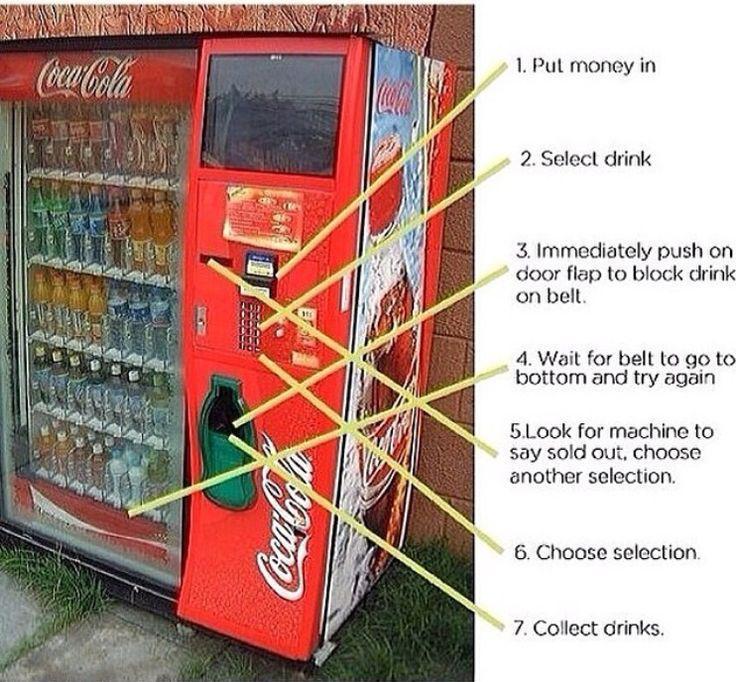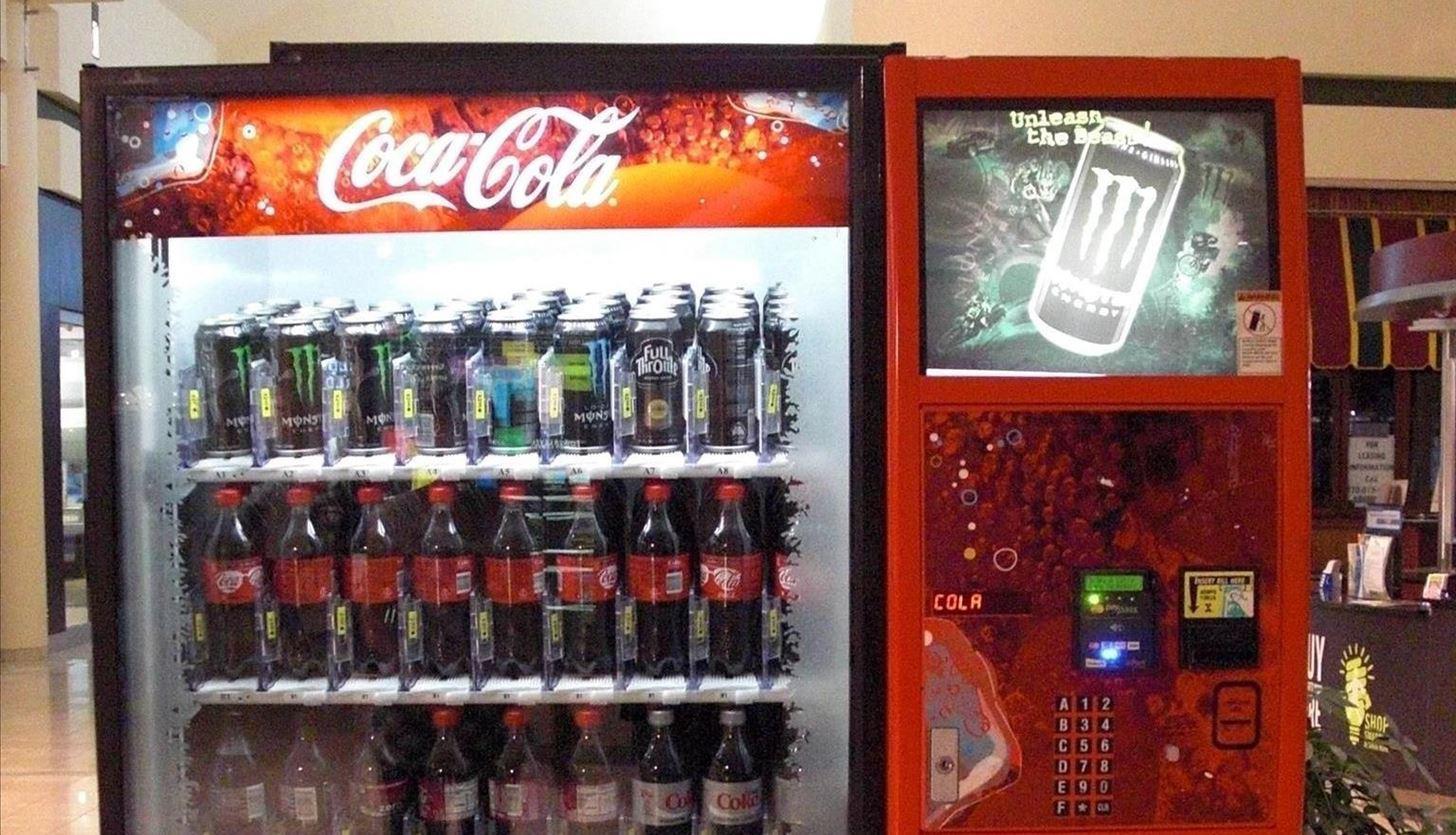The first image is the image on the left, the second image is the image on the right. For the images displayed, is the sentence "At least one image shows only beverage vending options." factually correct? Answer yes or no. Yes. 